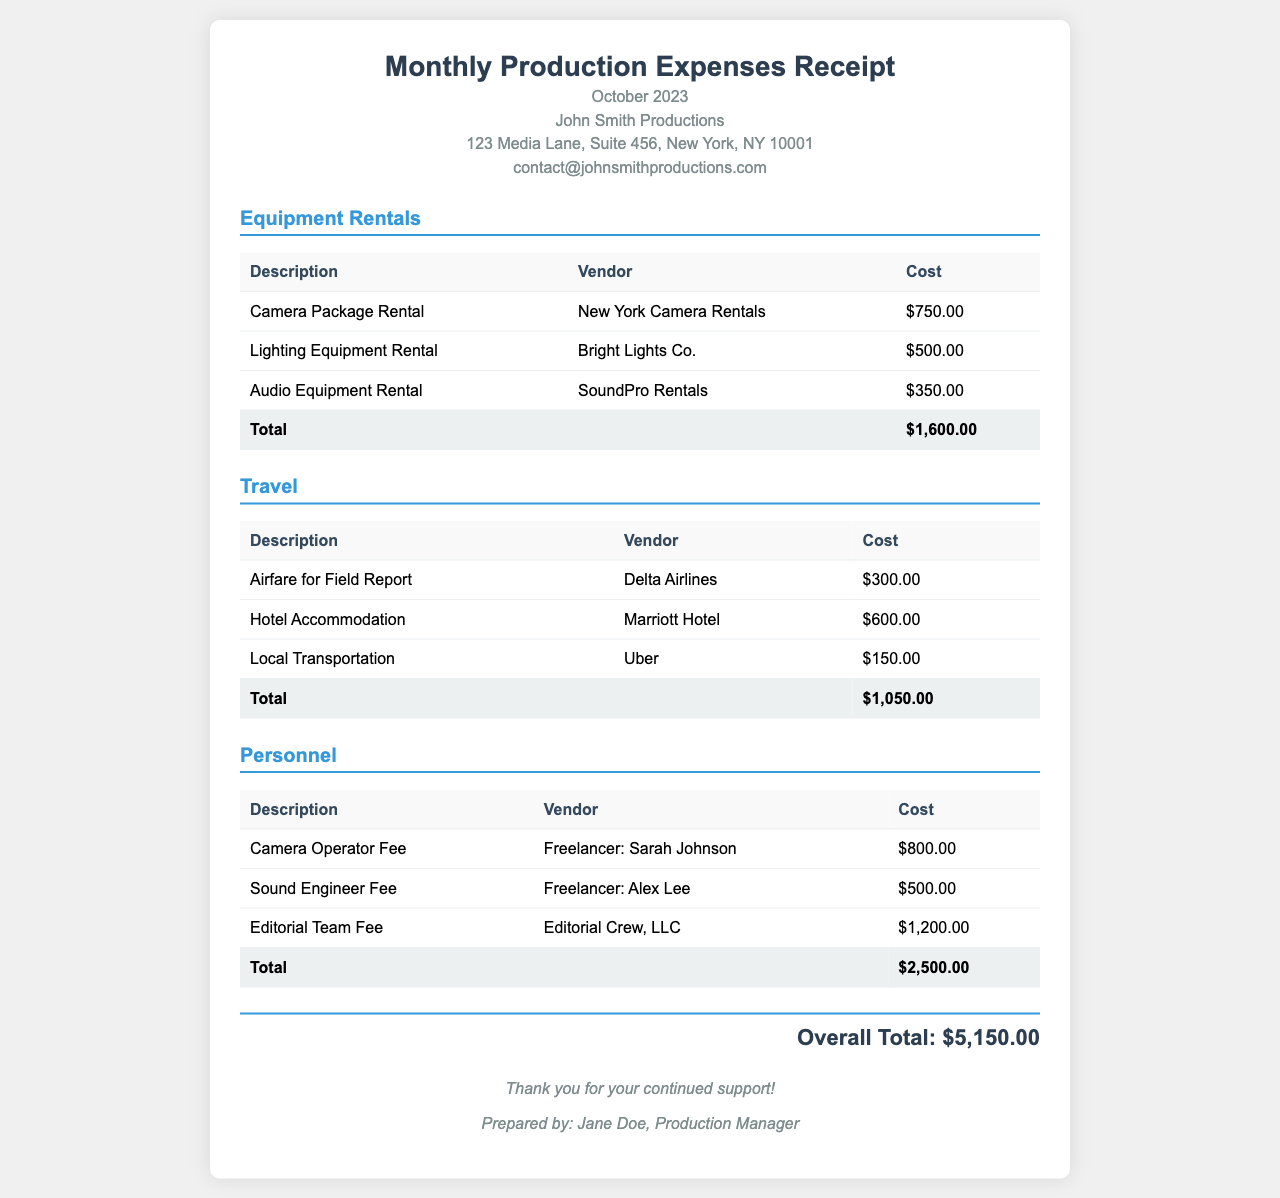What is the total cost for equipment rentals? The total cost for equipment rentals is the sum of the individual rental costs, which equals $750.00 + $500.00 + $350.00.
Answer: $1,600.00 Who is the production manager that prepared this receipt? The production manager's name is mentioned at the bottom of the receipt, highlighting their role in its preparation.
Answer: Jane Doe What was the cost for hotel accommodation? The cost for hotel accommodation is listed under the travel expenses section, specifically from the vendor information.
Answer: $600.00 What is the overall total for all expenses? The overall total summarizes all the categorized expenses from equipment rentals, travel, and personnel.
Answer: $5,150.00 How many personnel costs are listed in the document? The document provides a detailed list of personnel costs, each associated with a specific vendor name.
Answer: 3 